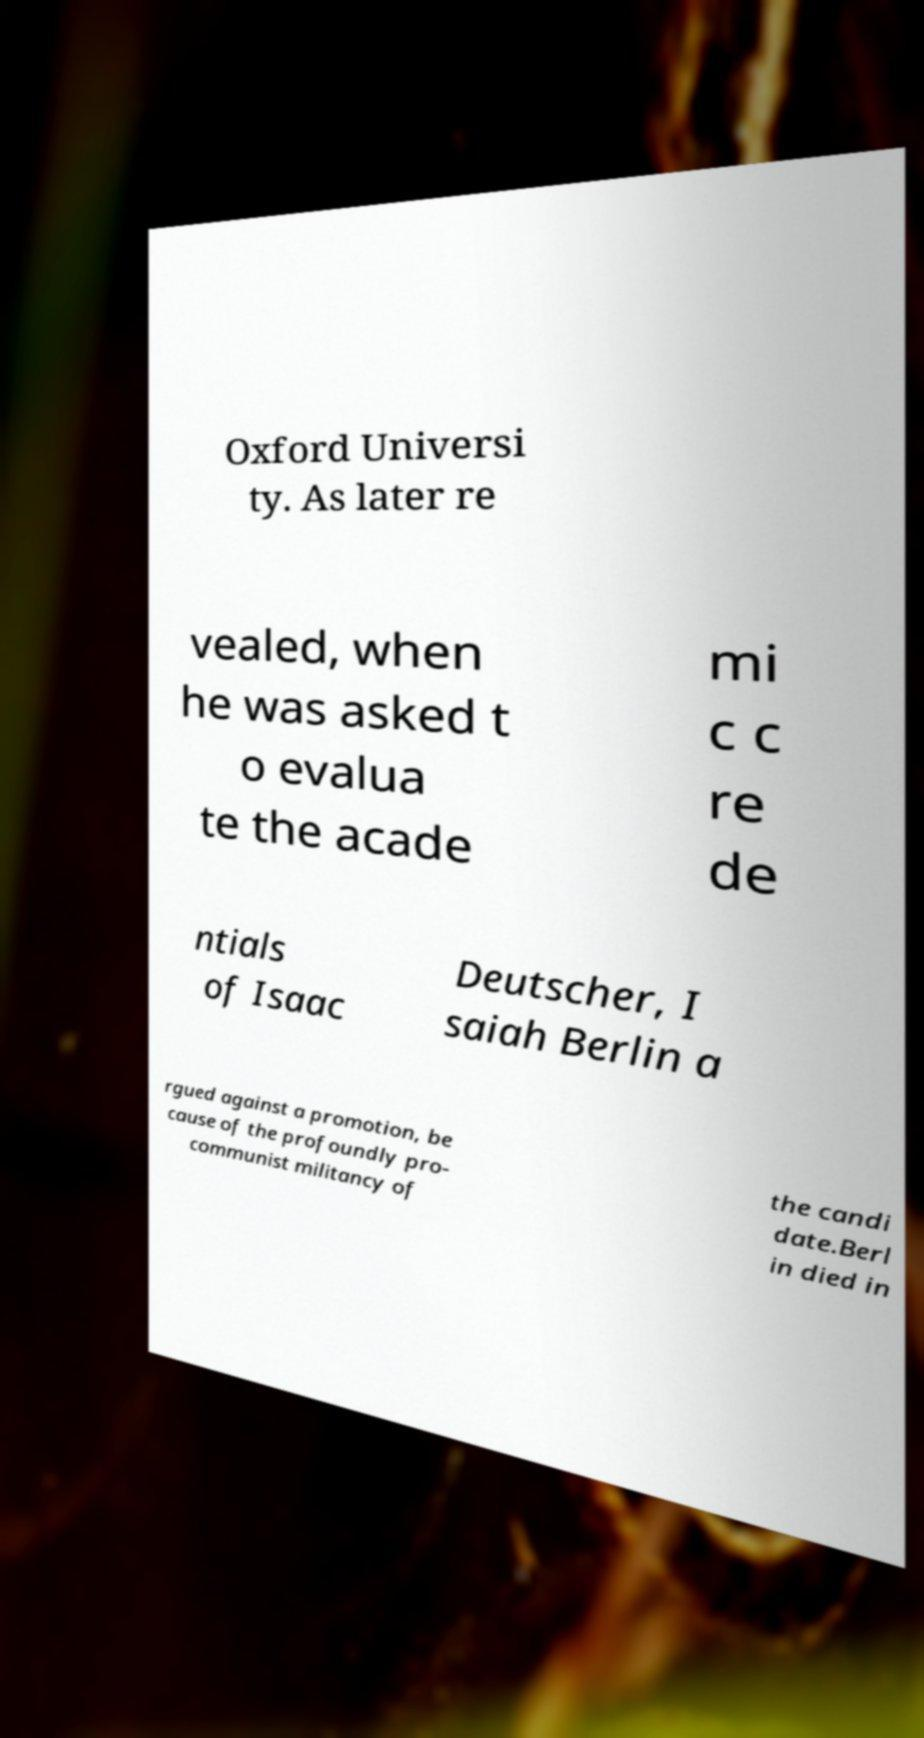What messages or text are displayed in this image? I need them in a readable, typed format. Oxford Universi ty. As later re vealed, when he was asked t o evalua te the acade mi c c re de ntials of Isaac Deutscher, I saiah Berlin a rgued against a promotion, be cause of the profoundly pro- communist militancy of the candi date.Berl in died in 